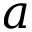<formula> <loc_0><loc_0><loc_500><loc_500>a</formula> 